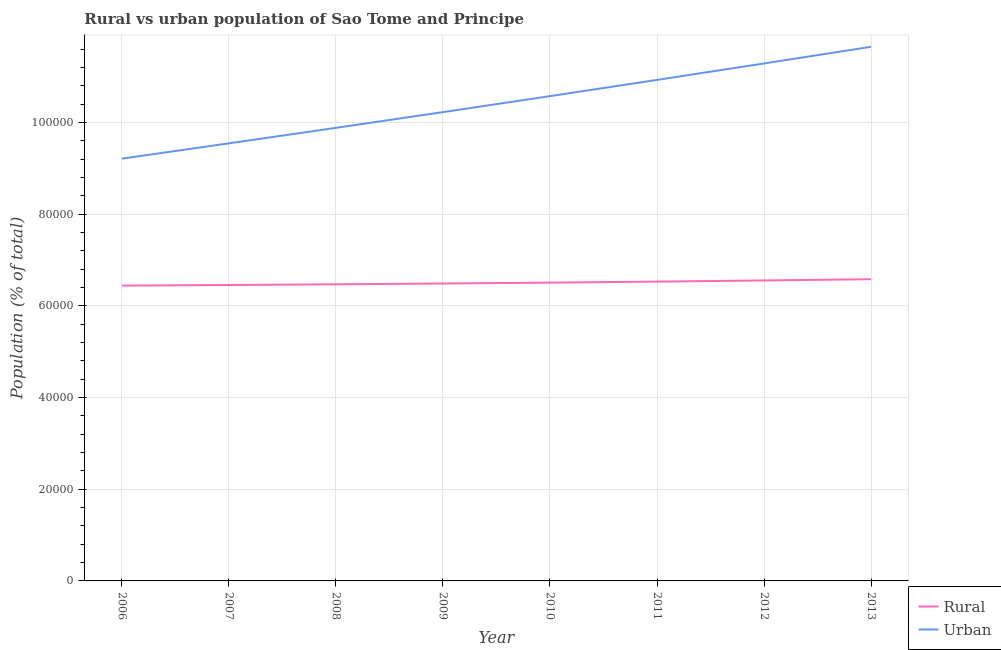What is the rural population density in 2012?
Ensure brevity in your answer.  6.56e+04. Across all years, what is the maximum urban population density?
Ensure brevity in your answer.  1.17e+05. Across all years, what is the minimum urban population density?
Your answer should be very brief. 9.21e+04. In which year was the rural population density maximum?
Ensure brevity in your answer.  2013. What is the total urban population density in the graph?
Your answer should be compact. 8.33e+05. What is the difference between the rural population density in 2007 and that in 2008?
Your answer should be very brief. -150. What is the difference between the rural population density in 2007 and the urban population density in 2008?
Your answer should be compact. -3.43e+04. What is the average rural population density per year?
Your answer should be very brief. 6.51e+04. In the year 2009, what is the difference between the urban population density and rural population density?
Ensure brevity in your answer.  3.74e+04. What is the ratio of the rural population density in 2010 to that in 2013?
Your answer should be very brief. 0.99. Is the urban population density in 2007 less than that in 2013?
Make the answer very short. Yes. What is the difference between the highest and the second highest rural population density?
Provide a succinct answer. 272. What is the difference between the highest and the lowest urban population density?
Your answer should be compact. 2.44e+04. In how many years, is the urban population density greater than the average urban population density taken over all years?
Your answer should be compact. 4. Is the rural population density strictly greater than the urban population density over the years?
Your answer should be very brief. No. Is the urban population density strictly less than the rural population density over the years?
Keep it short and to the point. No. Does the graph contain any zero values?
Keep it short and to the point. No. Does the graph contain grids?
Ensure brevity in your answer.  Yes. Where does the legend appear in the graph?
Provide a short and direct response. Bottom right. How many legend labels are there?
Your response must be concise. 2. How are the legend labels stacked?
Your answer should be very brief. Vertical. What is the title of the graph?
Keep it short and to the point. Rural vs urban population of Sao Tome and Principe. What is the label or title of the Y-axis?
Your answer should be very brief. Population (% of total). What is the Population (% of total) of Rural in 2006?
Provide a short and direct response. 6.44e+04. What is the Population (% of total) of Urban in 2006?
Provide a short and direct response. 9.21e+04. What is the Population (% of total) in Rural in 2007?
Provide a succinct answer. 6.46e+04. What is the Population (% of total) of Urban in 2007?
Provide a succinct answer. 9.55e+04. What is the Population (% of total) in Rural in 2008?
Offer a very short reply. 6.47e+04. What is the Population (% of total) of Urban in 2008?
Ensure brevity in your answer.  9.89e+04. What is the Population (% of total) in Rural in 2009?
Your answer should be very brief. 6.49e+04. What is the Population (% of total) in Urban in 2009?
Offer a very short reply. 1.02e+05. What is the Population (% of total) in Rural in 2010?
Offer a terse response. 6.51e+04. What is the Population (% of total) of Urban in 2010?
Offer a very short reply. 1.06e+05. What is the Population (% of total) of Rural in 2011?
Provide a short and direct response. 6.53e+04. What is the Population (% of total) in Urban in 2011?
Your answer should be very brief. 1.09e+05. What is the Population (% of total) of Rural in 2012?
Offer a terse response. 6.56e+04. What is the Population (% of total) of Urban in 2012?
Offer a terse response. 1.13e+05. What is the Population (% of total) in Rural in 2013?
Provide a succinct answer. 6.58e+04. What is the Population (% of total) in Urban in 2013?
Provide a short and direct response. 1.17e+05. Across all years, what is the maximum Population (% of total) of Rural?
Your answer should be very brief. 6.58e+04. Across all years, what is the maximum Population (% of total) of Urban?
Offer a very short reply. 1.17e+05. Across all years, what is the minimum Population (% of total) in Rural?
Provide a succinct answer. 6.44e+04. Across all years, what is the minimum Population (% of total) of Urban?
Provide a succinct answer. 9.21e+04. What is the total Population (% of total) of Rural in the graph?
Provide a succinct answer. 5.20e+05. What is the total Population (% of total) of Urban in the graph?
Keep it short and to the point. 8.33e+05. What is the difference between the Population (% of total) in Rural in 2006 and that in 2007?
Provide a succinct answer. -139. What is the difference between the Population (% of total) of Urban in 2006 and that in 2007?
Provide a succinct answer. -3341. What is the difference between the Population (% of total) in Rural in 2006 and that in 2008?
Your response must be concise. -289. What is the difference between the Population (% of total) in Urban in 2006 and that in 2008?
Keep it short and to the point. -6722. What is the difference between the Population (% of total) in Rural in 2006 and that in 2009?
Provide a short and direct response. -458. What is the difference between the Population (% of total) in Urban in 2006 and that in 2009?
Your answer should be compact. -1.02e+04. What is the difference between the Population (% of total) in Rural in 2006 and that in 2010?
Make the answer very short. -654. What is the difference between the Population (% of total) of Urban in 2006 and that in 2010?
Provide a short and direct response. -1.36e+04. What is the difference between the Population (% of total) of Rural in 2006 and that in 2011?
Offer a terse response. -879. What is the difference between the Population (% of total) of Urban in 2006 and that in 2011?
Keep it short and to the point. -1.72e+04. What is the difference between the Population (% of total) of Rural in 2006 and that in 2012?
Give a very brief answer. -1127. What is the difference between the Population (% of total) of Urban in 2006 and that in 2012?
Ensure brevity in your answer.  -2.08e+04. What is the difference between the Population (% of total) in Rural in 2006 and that in 2013?
Provide a succinct answer. -1399. What is the difference between the Population (% of total) of Urban in 2006 and that in 2013?
Give a very brief answer. -2.44e+04. What is the difference between the Population (% of total) in Rural in 2007 and that in 2008?
Your answer should be very brief. -150. What is the difference between the Population (% of total) in Urban in 2007 and that in 2008?
Offer a terse response. -3381. What is the difference between the Population (% of total) of Rural in 2007 and that in 2009?
Offer a terse response. -319. What is the difference between the Population (% of total) in Urban in 2007 and that in 2009?
Give a very brief answer. -6813. What is the difference between the Population (% of total) in Rural in 2007 and that in 2010?
Provide a short and direct response. -515. What is the difference between the Population (% of total) in Urban in 2007 and that in 2010?
Keep it short and to the point. -1.03e+04. What is the difference between the Population (% of total) of Rural in 2007 and that in 2011?
Your answer should be compact. -740. What is the difference between the Population (% of total) in Urban in 2007 and that in 2011?
Offer a very short reply. -1.38e+04. What is the difference between the Population (% of total) in Rural in 2007 and that in 2012?
Keep it short and to the point. -988. What is the difference between the Population (% of total) in Urban in 2007 and that in 2012?
Your response must be concise. -1.74e+04. What is the difference between the Population (% of total) in Rural in 2007 and that in 2013?
Keep it short and to the point. -1260. What is the difference between the Population (% of total) in Urban in 2007 and that in 2013?
Your response must be concise. -2.11e+04. What is the difference between the Population (% of total) of Rural in 2008 and that in 2009?
Keep it short and to the point. -169. What is the difference between the Population (% of total) in Urban in 2008 and that in 2009?
Offer a very short reply. -3432. What is the difference between the Population (% of total) in Rural in 2008 and that in 2010?
Offer a very short reply. -365. What is the difference between the Population (% of total) of Urban in 2008 and that in 2010?
Keep it short and to the point. -6920. What is the difference between the Population (% of total) of Rural in 2008 and that in 2011?
Your response must be concise. -590. What is the difference between the Population (% of total) of Urban in 2008 and that in 2011?
Your response must be concise. -1.05e+04. What is the difference between the Population (% of total) in Rural in 2008 and that in 2012?
Your answer should be very brief. -838. What is the difference between the Population (% of total) of Urban in 2008 and that in 2012?
Keep it short and to the point. -1.41e+04. What is the difference between the Population (% of total) in Rural in 2008 and that in 2013?
Provide a succinct answer. -1110. What is the difference between the Population (% of total) in Urban in 2008 and that in 2013?
Provide a short and direct response. -1.77e+04. What is the difference between the Population (% of total) in Rural in 2009 and that in 2010?
Offer a terse response. -196. What is the difference between the Population (% of total) in Urban in 2009 and that in 2010?
Your response must be concise. -3488. What is the difference between the Population (% of total) of Rural in 2009 and that in 2011?
Offer a terse response. -421. What is the difference between the Population (% of total) in Urban in 2009 and that in 2011?
Your answer should be compact. -7029. What is the difference between the Population (% of total) in Rural in 2009 and that in 2012?
Offer a terse response. -669. What is the difference between the Population (% of total) in Urban in 2009 and that in 2012?
Ensure brevity in your answer.  -1.06e+04. What is the difference between the Population (% of total) in Rural in 2009 and that in 2013?
Offer a very short reply. -941. What is the difference between the Population (% of total) of Urban in 2009 and that in 2013?
Your answer should be compact. -1.42e+04. What is the difference between the Population (% of total) of Rural in 2010 and that in 2011?
Your answer should be compact. -225. What is the difference between the Population (% of total) of Urban in 2010 and that in 2011?
Provide a succinct answer. -3541. What is the difference between the Population (% of total) in Rural in 2010 and that in 2012?
Provide a short and direct response. -473. What is the difference between the Population (% of total) in Urban in 2010 and that in 2012?
Offer a very short reply. -7131. What is the difference between the Population (% of total) of Rural in 2010 and that in 2013?
Make the answer very short. -745. What is the difference between the Population (% of total) of Urban in 2010 and that in 2013?
Ensure brevity in your answer.  -1.08e+04. What is the difference between the Population (% of total) of Rural in 2011 and that in 2012?
Give a very brief answer. -248. What is the difference between the Population (% of total) of Urban in 2011 and that in 2012?
Make the answer very short. -3590. What is the difference between the Population (% of total) of Rural in 2011 and that in 2013?
Provide a short and direct response. -520. What is the difference between the Population (% of total) of Urban in 2011 and that in 2013?
Offer a very short reply. -7220. What is the difference between the Population (% of total) of Rural in 2012 and that in 2013?
Provide a short and direct response. -272. What is the difference between the Population (% of total) in Urban in 2012 and that in 2013?
Make the answer very short. -3630. What is the difference between the Population (% of total) of Rural in 2006 and the Population (% of total) of Urban in 2007?
Keep it short and to the point. -3.10e+04. What is the difference between the Population (% of total) in Rural in 2006 and the Population (% of total) in Urban in 2008?
Ensure brevity in your answer.  -3.44e+04. What is the difference between the Population (% of total) in Rural in 2006 and the Population (% of total) in Urban in 2009?
Your answer should be very brief. -3.79e+04. What is the difference between the Population (% of total) in Rural in 2006 and the Population (% of total) in Urban in 2010?
Offer a terse response. -4.13e+04. What is the difference between the Population (% of total) in Rural in 2006 and the Population (% of total) in Urban in 2011?
Make the answer very short. -4.49e+04. What is the difference between the Population (% of total) of Rural in 2006 and the Population (% of total) of Urban in 2012?
Provide a succinct answer. -4.85e+04. What is the difference between the Population (% of total) of Rural in 2006 and the Population (% of total) of Urban in 2013?
Give a very brief answer. -5.21e+04. What is the difference between the Population (% of total) in Rural in 2007 and the Population (% of total) in Urban in 2008?
Offer a very short reply. -3.43e+04. What is the difference between the Population (% of total) of Rural in 2007 and the Population (% of total) of Urban in 2009?
Your response must be concise. -3.77e+04. What is the difference between the Population (% of total) of Rural in 2007 and the Population (% of total) of Urban in 2010?
Offer a very short reply. -4.12e+04. What is the difference between the Population (% of total) in Rural in 2007 and the Population (% of total) in Urban in 2011?
Your answer should be very brief. -4.48e+04. What is the difference between the Population (% of total) in Rural in 2007 and the Population (% of total) in Urban in 2012?
Your response must be concise. -4.83e+04. What is the difference between the Population (% of total) of Rural in 2007 and the Population (% of total) of Urban in 2013?
Give a very brief answer. -5.20e+04. What is the difference between the Population (% of total) of Rural in 2008 and the Population (% of total) of Urban in 2009?
Your answer should be compact. -3.76e+04. What is the difference between the Population (% of total) in Rural in 2008 and the Population (% of total) in Urban in 2010?
Your answer should be very brief. -4.11e+04. What is the difference between the Population (% of total) of Rural in 2008 and the Population (% of total) of Urban in 2011?
Your answer should be very brief. -4.46e+04. What is the difference between the Population (% of total) in Rural in 2008 and the Population (% of total) in Urban in 2012?
Give a very brief answer. -4.82e+04. What is the difference between the Population (% of total) in Rural in 2008 and the Population (% of total) in Urban in 2013?
Your answer should be compact. -5.18e+04. What is the difference between the Population (% of total) in Rural in 2009 and the Population (% of total) in Urban in 2010?
Your answer should be compact. -4.09e+04. What is the difference between the Population (% of total) in Rural in 2009 and the Population (% of total) in Urban in 2011?
Give a very brief answer. -4.44e+04. What is the difference between the Population (% of total) in Rural in 2009 and the Population (% of total) in Urban in 2012?
Give a very brief answer. -4.80e+04. What is the difference between the Population (% of total) in Rural in 2009 and the Population (% of total) in Urban in 2013?
Offer a terse response. -5.17e+04. What is the difference between the Population (% of total) in Rural in 2010 and the Population (% of total) in Urban in 2011?
Your answer should be compact. -4.42e+04. What is the difference between the Population (% of total) in Rural in 2010 and the Population (% of total) in Urban in 2012?
Ensure brevity in your answer.  -4.78e+04. What is the difference between the Population (% of total) of Rural in 2010 and the Population (% of total) of Urban in 2013?
Offer a terse response. -5.15e+04. What is the difference between the Population (% of total) in Rural in 2011 and the Population (% of total) in Urban in 2012?
Offer a very short reply. -4.76e+04. What is the difference between the Population (% of total) in Rural in 2011 and the Population (% of total) in Urban in 2013?
Provide a succinct answer. -5.12e+04. What is the difference between the Population (% of total) in Rural in 2012 and the Population (% of total) in Urban in 2013?
Give a very brief answer. -5.10e+04. What is the average Population (% of total) of Rural per year?
Your response must be concise. 6.51e+04. What is the average Population (% of total) of Urban per year?
Make the answer very short. 1.04e+05. In the year 2006, what is the difference between the Population (% of total) of Rural and Population (% of total) of Urban?
Make the answer very short. -2.77e+04. In the year 2007, what is the difference between the Population (% of total) of Rural and Population (% of total) of Urban?
Offer a very short reply. -3.09e+04. In the year 2008, what is the difference between the Population (% of total) in Rural and Population (% of total) in Urban?
Make the answer very short. -3.41e+04. In the year 2009, what is the difference between the Population (% of total) in Rural and Population (% of total) in Urban?
Make the answer very short. -3.74e+04. In the year 2010, what is the difference between the Population (% of total) in Rural and Population (% of total) in Urban?
Give a very brief answer. -4.07e+04. In the year 2011, what is the difference between the Population (% of total) of Rural and Population (% of total) of Urban?
Offer a very short reply. -4.40e+04. In the year 2012, what is the difference between the Population (% of total) of Rural and Population (% of total) of Urban?
Your answer should be very brief. -4.74e+04. In the year 2013, what is the difference between the Population (% of total) of Rural and Population (% of total) of Urban?
Your answer should be very brief. -5.07e+04. What is the ratio of the Population (% of total) of Urban in 2006 to that in 2008?
Keep it short and to the point. 0.93. What is the ratio of the Population (% of total) of Urban in 2006 to that in 2009?
Give a very brief answer. 0.9. What is the ratio of the Population (% of total) in Urban in 2006 to that in 2010?
Provide a short and direct response. 0.87. What is the ratio of the Population (% of total) of Rural in 2006 to that in 2011?
Your answer should be compact. 0.99. What is the ratio of the Population (% of total) of Urban in 2006 to that in 2011?
Ensure brevity in your answer.  0.84. What is the ratio of the Population (% of total) of Rural in 2006 to that in 2012?
Your answer should be compact. 0.98. What is the ratio of the Population (% of total) in Urban in 2006 to that in 2012?
Offer a terse response. 0.82. What is the ratio of the Population (% of total) of Rural in 2006 to that in 2013?
Provide a succinct answer. 0.98. What is the ratio of the Population (% of total) of Urban in 2006 to that in 2013?
Offer a very short reply. 0.79. What is the ratio of the Population (% of total) in Urban in 2007 to that in 2008?
Keep it short and to the point. 0.97. What is the ratio of the Population (% of total) of Urban in 2007 to that in 2009?
Provide a succinct answer. 0.93. What is the ratio of the Population (% of total) in Urban in 2007 to that in 2010?
Ensure brevity in your answer.  0.9. What is the ratio of the Population (% of total) of Rural in 2007 to that in 2011?
Offer a very short reply. 0.99. What is the ratio of the Population (% of total) in Urban in 2007 to that in 2011?
Provide a short and direct response. 0.87. What is the ratio of the Population (% of total) in Rural in 2007 to that in 2012?
Offer a very short reply. 0.98. What is the ratio of the Population (% of total) of Urban in 2007 to that in 2012?
Ensure brevity in your answer.  0.85. What is the ratio of the Population (% of total) in Rural in 2007 to that in 2013?
Offer a terse response. 0.98. What is the ratio of the Population (% of total) in Urban in 2007 to that in 2013?
Offer a terse response. 0.82. What is the ratio of the Population (% of total) of Urban in 2008 to that in 2009?
Your response must be concise. 0.97. What is the ratio of the Population (% of total) of Rural in 2008 to that in 2010?
Make the answer very short. 0.99. What is the ratio of the Population (% of total) in Urban in 2008 to that in 2010?
Ensure brevity in your answer.  0.93. What is the ratio of the Population (% of total) in Urban in 2008 to that in 2011?
Provide a succinct answer. 0.9. What is the ratio of the Population (% of total) in Rural in 2008 to that in 2012?
Make the answer very short. 0.99. What is the ratio of the Population (% of total) in Urban in 2008 to that in 2012?
Offer a terse response. 0.88. What is the ratio of the Population (% of total) of Rural in 2008 to that in 2013?
Provide a succinct answer. 0.98. What is the ratio of the Population (% of total) of Urban in 2008 to that in 2013?
Provide a succinct answer. 0.85. What is the ratio of the Population (% of total) in Rural in 2009 to that in 2011?
Your response must be concise. 0.99. What is the ratio of the Population (% of total) in Urban in 2009 to that in 2011?
Your answer should be compact. 0.94. What is the ratio of the Population (% of total) of Urban in 2009 to that in 2012?
Give a very brief answer. 0.91. What is the ratio of the Population (% of total) in Rural in 2009 to that in 2013?
Offer a very short reply. 0.99. What is the ratio of the Population (% of total) of Urban in 2009 to that in 2013?
Give a very brief answer. 0.88. What is the ratio of the Population (% of total) of Urban in 2010 to that in 2011?
Your answer should be compact. 0.97. What is the ratio of the Population (% of total) in Urban in 2010 to that in 2012?
Your answer should be compact. 0.94. What is the ratio of the Population (% of total) of Rural in 2010 to that in 2013?
Make the answer very short. 0.99. What is the ratio of the Population (% of total) of Urban in 2010 to that in 2013?
Provide a short and direct response. 0.91. What is the ratio of the Population (% of total) in Rural in 2011 to that in 2012?
Your answer should be very brief. 1. What is the ratio of the Population (% of total) in Urban in 2011 to that in 2012?
Provide a short and direct response. 0.97. What is the ratio of the Population (% of total) of Rural in 2011 to that in 2013?
Offer a very short reply. 0.99. What is the ratio of the Population (% of total) in Urban in 2011 to that in 2013?
Your answer should be compact. 0.94. What is the ratio of the Population (% of total) of Urban in 2012 to that in 2013?
Offer a very short reply. 0.97. What is the difference between the highest and the second highest Population (% of total) of Rural?
Offer a very short reply. 272. What is the difference between the highest and the second highest Population (% of total) of Urban?
Your response must be concise. 3630. What is the difference between the highest and the lowest Population (% of total) in Rural?
Keep it short and to the point. 1399. What is the difference between the highest and the lowest Population (% of total) of Urban?
Make the answer very short. 2.44e+04. 